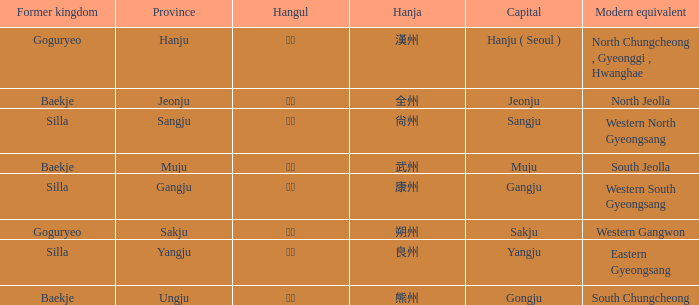What is the modern equivalent of the former kingdom "silla" with the hanja 尙州? 1.0. Would you mind parsing the complete table? {'header': ['Former kingdom', 'Province', 'Hangul', 'Hanja', 'Capital', 'Modern equivalent'], 'rows': [['Goguryeo', 'Hanju', '한주', '漢州', 'Hanju ( Seoul )', 'North Chungcheong , Gyeonggi , Hwanghae'], ['Baekje', 'Jeonju', '전주', '全州', 'Jeonju', 'North Jeolla'], ['Silla', 'Sangju', '상주', '尙州', 'Sangju', 'Western North Gyeongsang'], ['Baekje', 'Muju', '무주', '武州', 'Muju', 'South Jeolla'], ['Silla', 'Gangju', '강주', '康州', 'Gangju', 'Western South Gyeongsang'], ['Goguryeo', 'Sakju', '삭주', '朔州', 'Sakju', 'Western Gangwon'], ['Silla', 'Yangju', '양주', '良州', 'Yangju', 'Eastern Gyeongsang'], ['Baekje', 'Ungju', '웅주', '熊州', 'Gongju', 'South Chungcheong']]} 